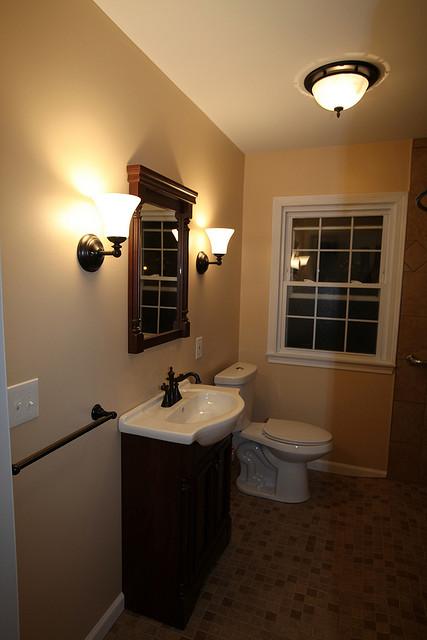Does the window have a curtain?
Quick response, please. No. How many lights are on?
Be succinct. 3. Is this an old-fashioned sink?
Quick response, please. No. 